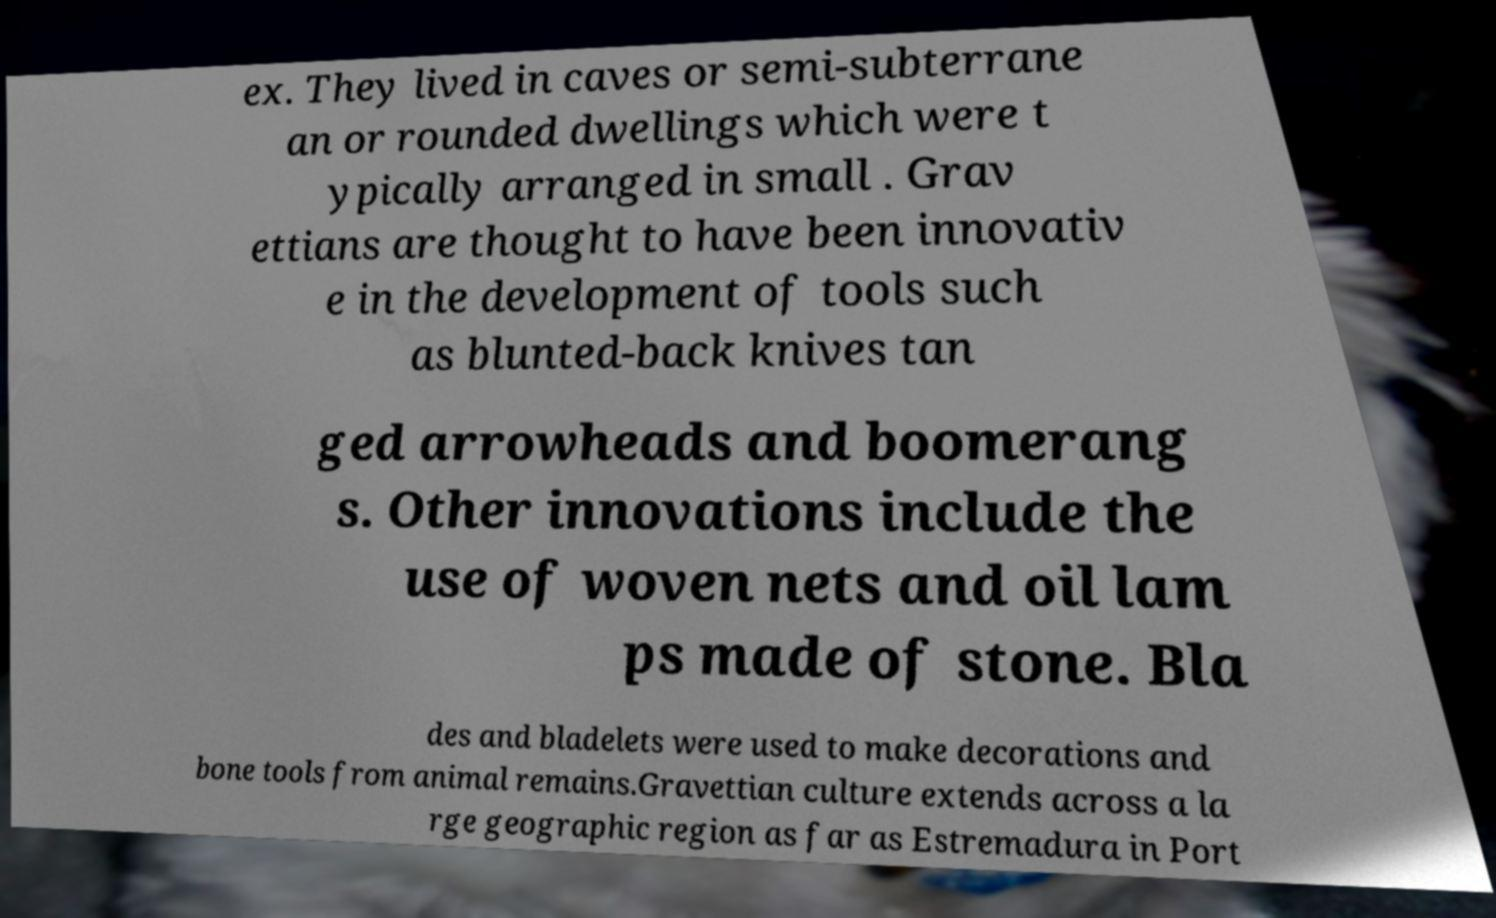Can you accurately transcribe the text from the provided image for me? ex. They lived in caves or semi-subterrane an or rounded dwellings which were t ypically arranged in small . Grav ettians are thought to have been innovativ e in the development of tools such as blunted-back knives tan ged arrowheads and boomerang s. Other innovations include the use of woven nets and oil lam ps made of stone. Bla des and bladelets were used to make decorations and bone tools from animal remains.Gravettian culture extends across a la rge geographic region as far as Estremadura in Port 